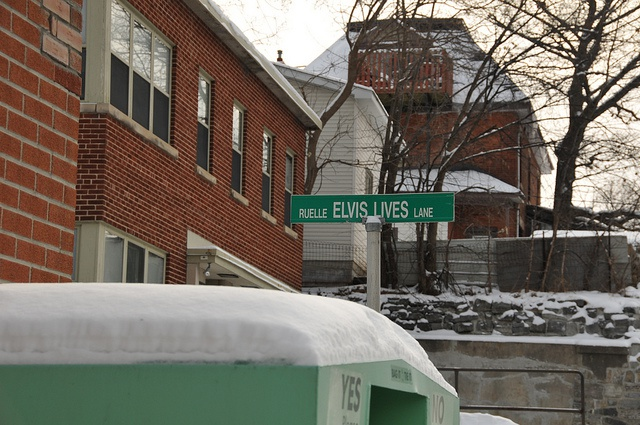Describe the objects in this image and their specific colors. I can see various objects in this image with different colors. 